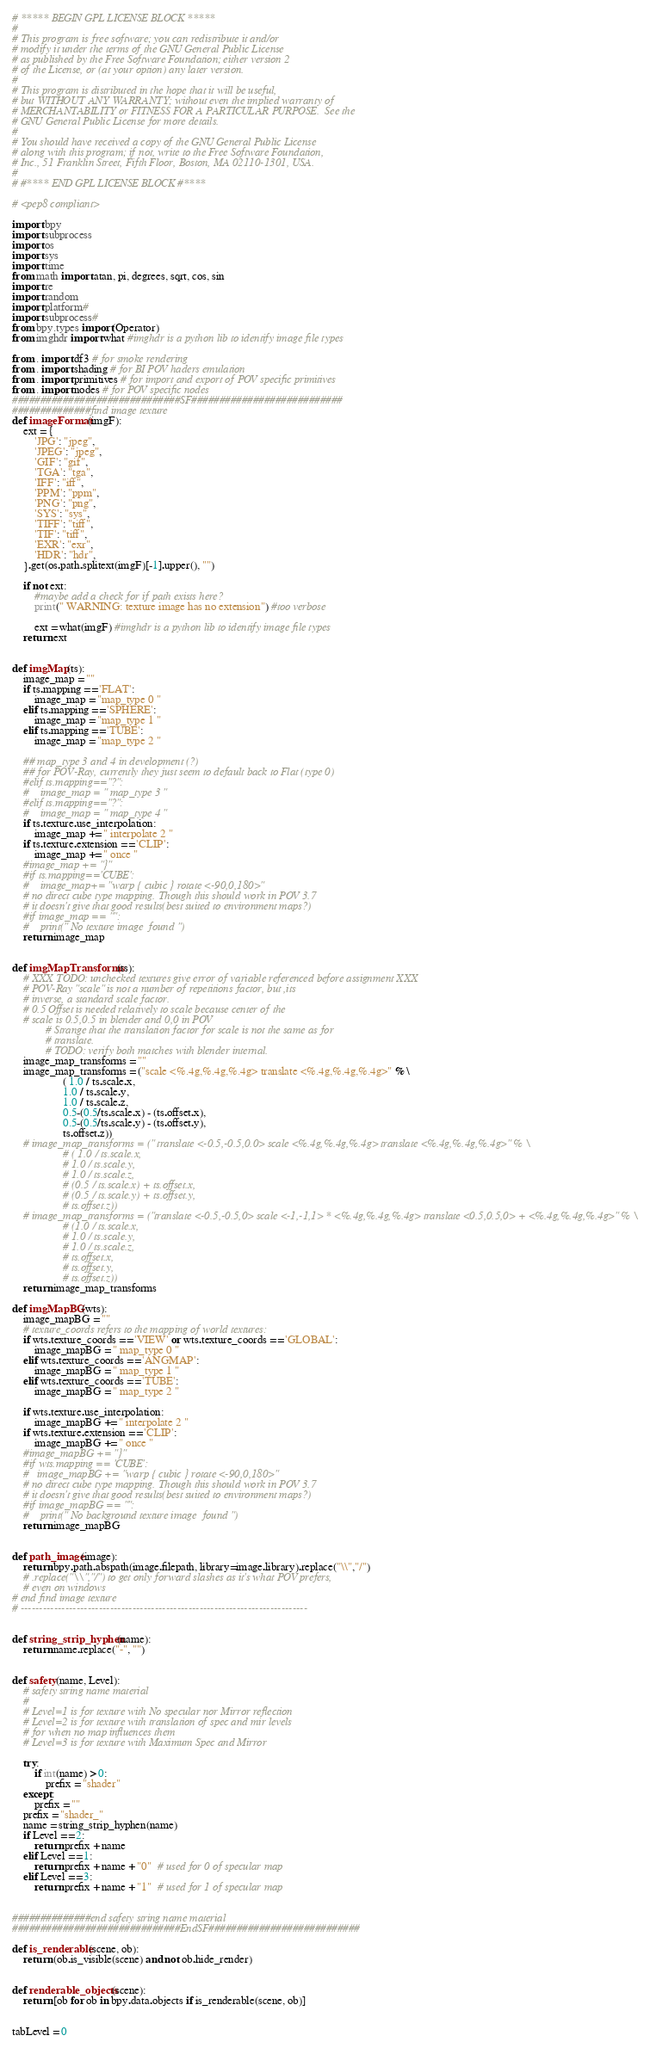<code> <loc_0><loc_0><loc_500><loc_500><_Python_># ***** BEGIN GPL LICENSE BLOCK *****
#
# This program is free software; you can redistribute it and/or
# modify it under the terms of the GNU General Public License
# as published by the Free Software Foundation; either version 2
# of the License, or (at your option) any later version.
#
# This program is distributed in the hope that it will be useful,
# but WITHOUT ANY WARRANTY; without even the implied warranty of
# MERCHANTABILITY or FITNESS FOR A PARTICULAR PURPOSE.  See the
# GNU General Public License for more details.
#
# You should have received a copy of the GNU General Public License
# along with this program; if not, write to the Free Software Foundation,
# Inc., 51 Franklin Street, Fifth Floor, Boston, MA 02110-1301, USA.
#
# #**** END GPL LICENSE BLOCK #****

# <pep8 compliant>

import bpy
import subprocess
import os
import sys
import time
from math import atan, pi, degrees, sqrt, cos, sin
import re
import random
import platform#
import subprocess#
from bpy.types import(Operator)
from imghdr import what #imghdr is a python lib to identify image file types

from . import df3 # for smoke rendering
from . import shading # for BI POV haders emulation
from . import primitives # for import and export of POV specific primitives
from . import nodes # for POV specific nodes
##############################SF###########################
##############find image texture
def imageFormat(imgF):
    ext = {
        'JPG': "jpeg",
        'JPEG': "jpeg",
        'GIF': "gif",
        'TGA': "tga",
        'IFF': "iff",
        'PPM': "ppm",
        'PNG': "png",
        'SYS': "sys",
        'TIFF': "tiff",
        'TIF': "tiff",
        'EXR': "exr",
        'HDR': "hdr",
    }.get(os.path.splitext(imgF)[-1].upper(), "")

    if not ext:
        #maybe add a check for if path exists here?
        print(" WARNING: texture image has no extension") #too verbose

        ext = what(imgF) #imghdr is a python lib to identify image file types
    return ext


def imgMap(ts):
    image_map = ""
    if ts.mapping == 'FLAT':
        image_map = "map_type 0 "
    elif ts.mapping == 'SPHERE':
        image_map = "map_type 1 "
    elif ts.mapping == 'TUBE':
        image_map = "map_type 2 "

    ## map_type 3 and 4 in development (?)
    ## for POV-Ray, currently they just seem to default back to Flat (type 0)
    #elif ts.mapping=="?":
    #    image_map = " map_type 3 "
    #elif ts.mapping=="?":
    #    image_map = " map_type 4 "
    if ts.texture.use_interpolation:
        image_map += " interpolate 2 "
    if ts.texture.extension == 'CLIP':
        image_map += " once "
    #image_map += "}"
    #if ts.mapping=='CUBE':
    #    image_map+= "warp { cubic } rotate <-90,0,180>"
    # no direct cube type mapping. Though this should work in POV 3.7
    # it doesn't give that good results(best suited to environment maps?)
    #if image_map == "":
    #    print(" No texture image  found ")
    return image_map


def imgMapTransforms(ts):
    # XXX TODO: unchecked textures give error of variable referenced before assignment XXX
    # POV-Ray "scale" is not a number of repetitions factor, but ,its
    # inverse, a standard scale factor.
    # 0.5 Offset is needed relatively to scale because center of the
    # scale is 0.5,0.5 in blender and 0,0 in POV
            # Strange that the translation factor for scale is not the same as for
            # translate.
            # TODO: verify both matches with blender internal.
    image_map_transforms = ""
    image_map_transforms = ("scale <%.4g,%.4g,%.4g> translate <%.4g,%.4g,%.4g>" % \
                  ( 1.0 / ts.scale.x,
                  1.0 / ts.scale.y,
                  1.0 / ts.scale.z,
                  0.5-(0.5/ts.scale.x) - (ts.offset.x),
                  0.5-(0.5/ts.scale.y) - (ts.offset.y),
                  ts.offset.z))
    # image_map_transforms = (" translate <-0.5,-0.5,0.0> scale <%.4g,%.4g,%.4g> translate <%.4g,%.4g,%.4g>" % \
                  # ( 1.0 / ts.scale.x,
                  # 1.0 / ts.scale.y,
                  # 1.0 / ts.scale.z,
                  # (0.5 / ts.scale.x) + ts.offset.x,
                  # (0.5 / ts.scale.y) + ts.offset.y,
                  # ts.offset.z))
    # image_map_transforms = ("translate <-0.5,-0.5,0> scale <-1,-1,1> * <%.4g,%.4g,%.4g> translate <0.5,0.5,0> + <%.4g,%.4g,%.4g>" % \
                  # (1.0 / ts.scale.x,
                  # 1.0 / ts.scale.y,
                  # 1.0 / ts.scale.z,
                  # ts.offset.x,
                  # ts.offset.y,
                  # ts.offset.z))
    return image_map_transforms

def imgMapBG(wts):
    image_mapBG = ""
    # texture_coords refers to the mapping of world textures:
    if wts.texture_coords == 'VIEW' or wts.texture_coords == 'GLOBAL':
        image_mapBG = " map_type 0 "
    elif wts.texture_coords == 'ANGMAP':
        image_mapBG = " map_type 1 "
    elif wts.texture_coords == 'TUBE':
        image_mapBG = " map_type 2 "

    if wts.texture.use_interpolation:
        image_mapBG += " interpolate 2 "
    if wts.texture.extension == 'CLIP':
        image_mapBG += " once "
    #image_mapBG += "}"
    #if wts.mapping == 'CUBE':
    #   image_mapBG += "warp { cubic } rotate <-90,0,180>"
    # no direct cube type mapping. Though this should work in POV 3.7
    # it doesn't give that good results(best suited to environment maps?)
    #if image_mapBG == "":
    #    print(" No background texture image  found ")
    return image_mapBG


def path_image(image):
    return bpy.path.abspath(image.filepath, library=image.library).replace("\\","/")
    # .replace("\\","/") to get only forward slashes as it's what POV prefers,
    # even on windows
# end find image texture
# -----------------------------------------------------------------------------


def string_strip_hyphen(name):
    return name.replace("-", "")


def safety(name, Level):
    # safety string name material
    #
    # Level=1 is for texture with No specular nor Mirror reflection
    # Level=2 is for texture with translation of spec and mir levels
    # for when no map influences them
    # Level=3 is for texture with Maximum Spec and Mirror

    try:
        if int(name) > 0:
            prefix = "shader"
    except:
        prefix = ""
    prefix = "shader_"
    name = string_strip_hyphen(name)
    if Level == 2:
        return prefix + name
    elif Level == 1:
        return prefix + name + "0"  # used for 0 of specular map
    elif Level == 3:
        return prefix + name + "1"  # used for 1 of specular map


##############end safety string name material
##############################EndSF###########################

def is_renderable(scene, ob):
    return (ob.is_visible(scene) and not ob.hide_render)


def renderable_objects(scene):
    return [ob for ob in bpy.data.objects if is_renderable(scene, ob)]


tabLevel = 0</code> 